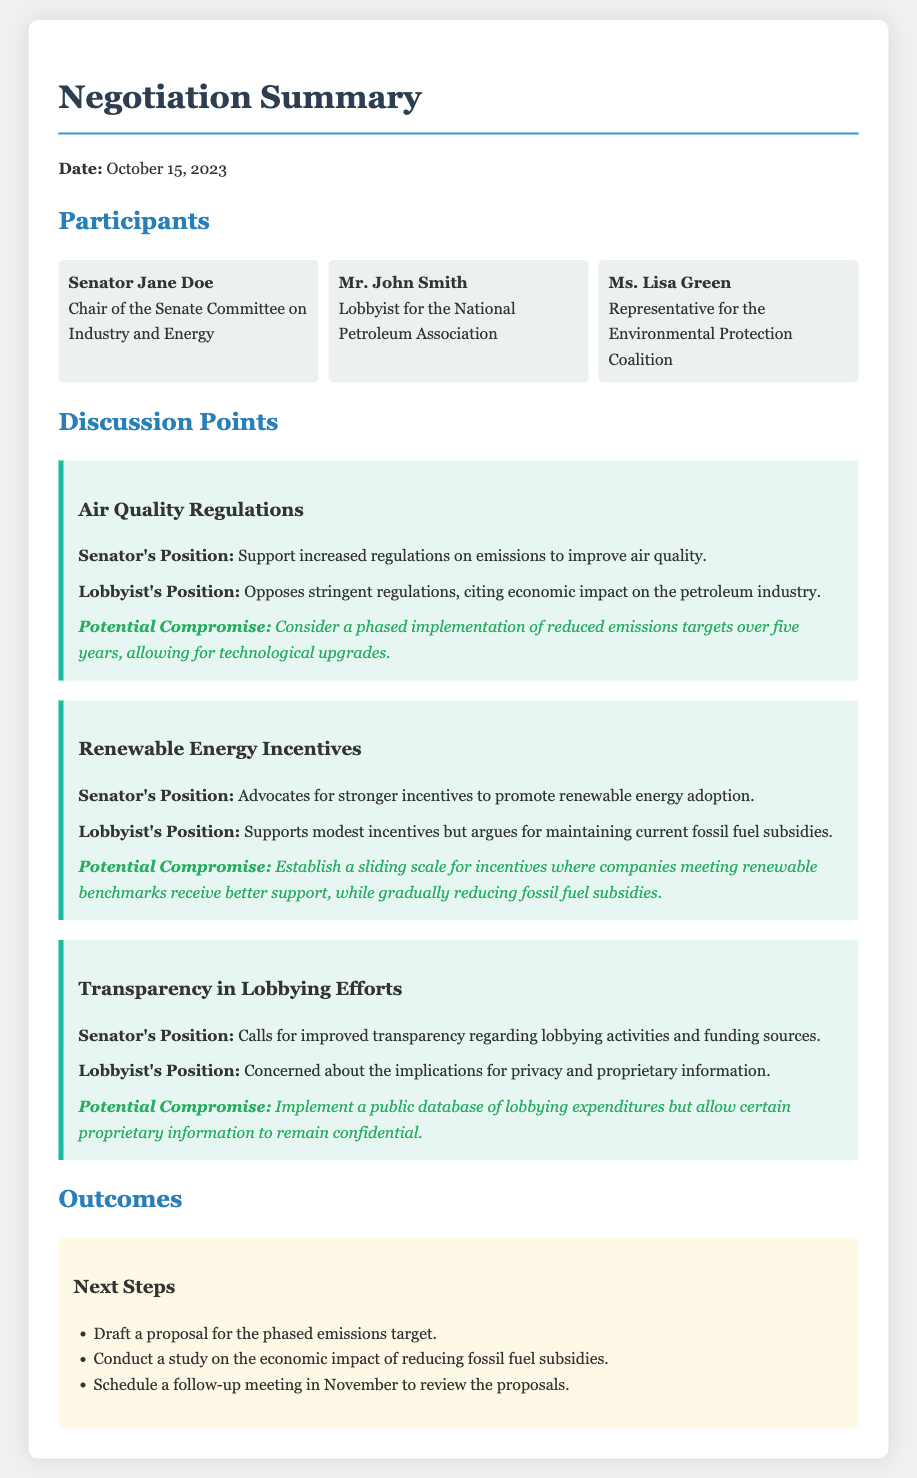What is the date of the negotiation? The date of the negotiation is mentioned at the beginning of the document.
Answer: October 15, 2023 Who is the Chair of the Senate Committee on Industry and Energy? This information is provided under the participants' section of the document.
Answer: Senator Jane Doe What is the lobbyist's position on Air Quality Regulations? The document states the lobbyist's position regarding air quality regulations in the discussion points.
Answer: Opposes stringent regulations, citing economic impact on the petroleum industry What is the proposed timeframe for the phased implementation of reduced emissions targets? This information can be found in the compromise section regarding Air Quality Regulations.
Answer: Five years What action is planned as a next step regarding fossil fuel subsidies? The document lists this action under the outcomes section of the negotiation summary.
Answer: Conduct a study on the economic impact of reducing fossil fuel subsidies What does the Senator advocate for regarding Renewable Energy Incentives? The senator's advocacy on renewable energy incentives is noted under the discussion points.
Answer: Stronger incentives to promote renewable energy adoption What compromise is suggested for maintaining transparency in lobbying activities? The document explains the proposed compromise about lobbying transparency in the discussion points section.
Answer: Implement a public database of lobbying expenditures but allow certain proprietary information to remain confidential Who is the representative for the Environmental Protection Coalition? This information is found in the participants' section of the document.
Answer: Ms. Lisa Green 